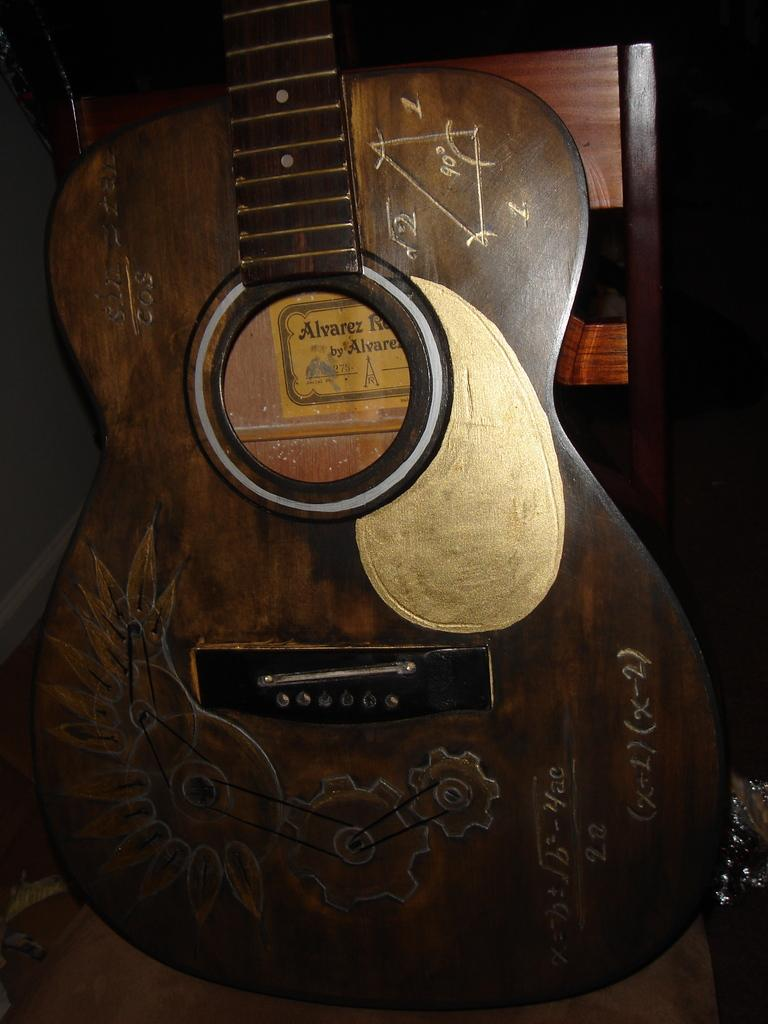What musical instrument is present in the image? The image contains a guitar. What material is the guitar made of? The guitar is made of wood. What is written on the guitar? There are formulas written on the guitar. Are there any additional decorations on the guitar? Yes, there is a sticker on the guitar. What can be seen behind the guitar in the image? There is a wooden wall behind the guitar. What advice can be seen written on the calculator in the image? There is no calculator present in the image; it features a guitar with formulas written on it. 